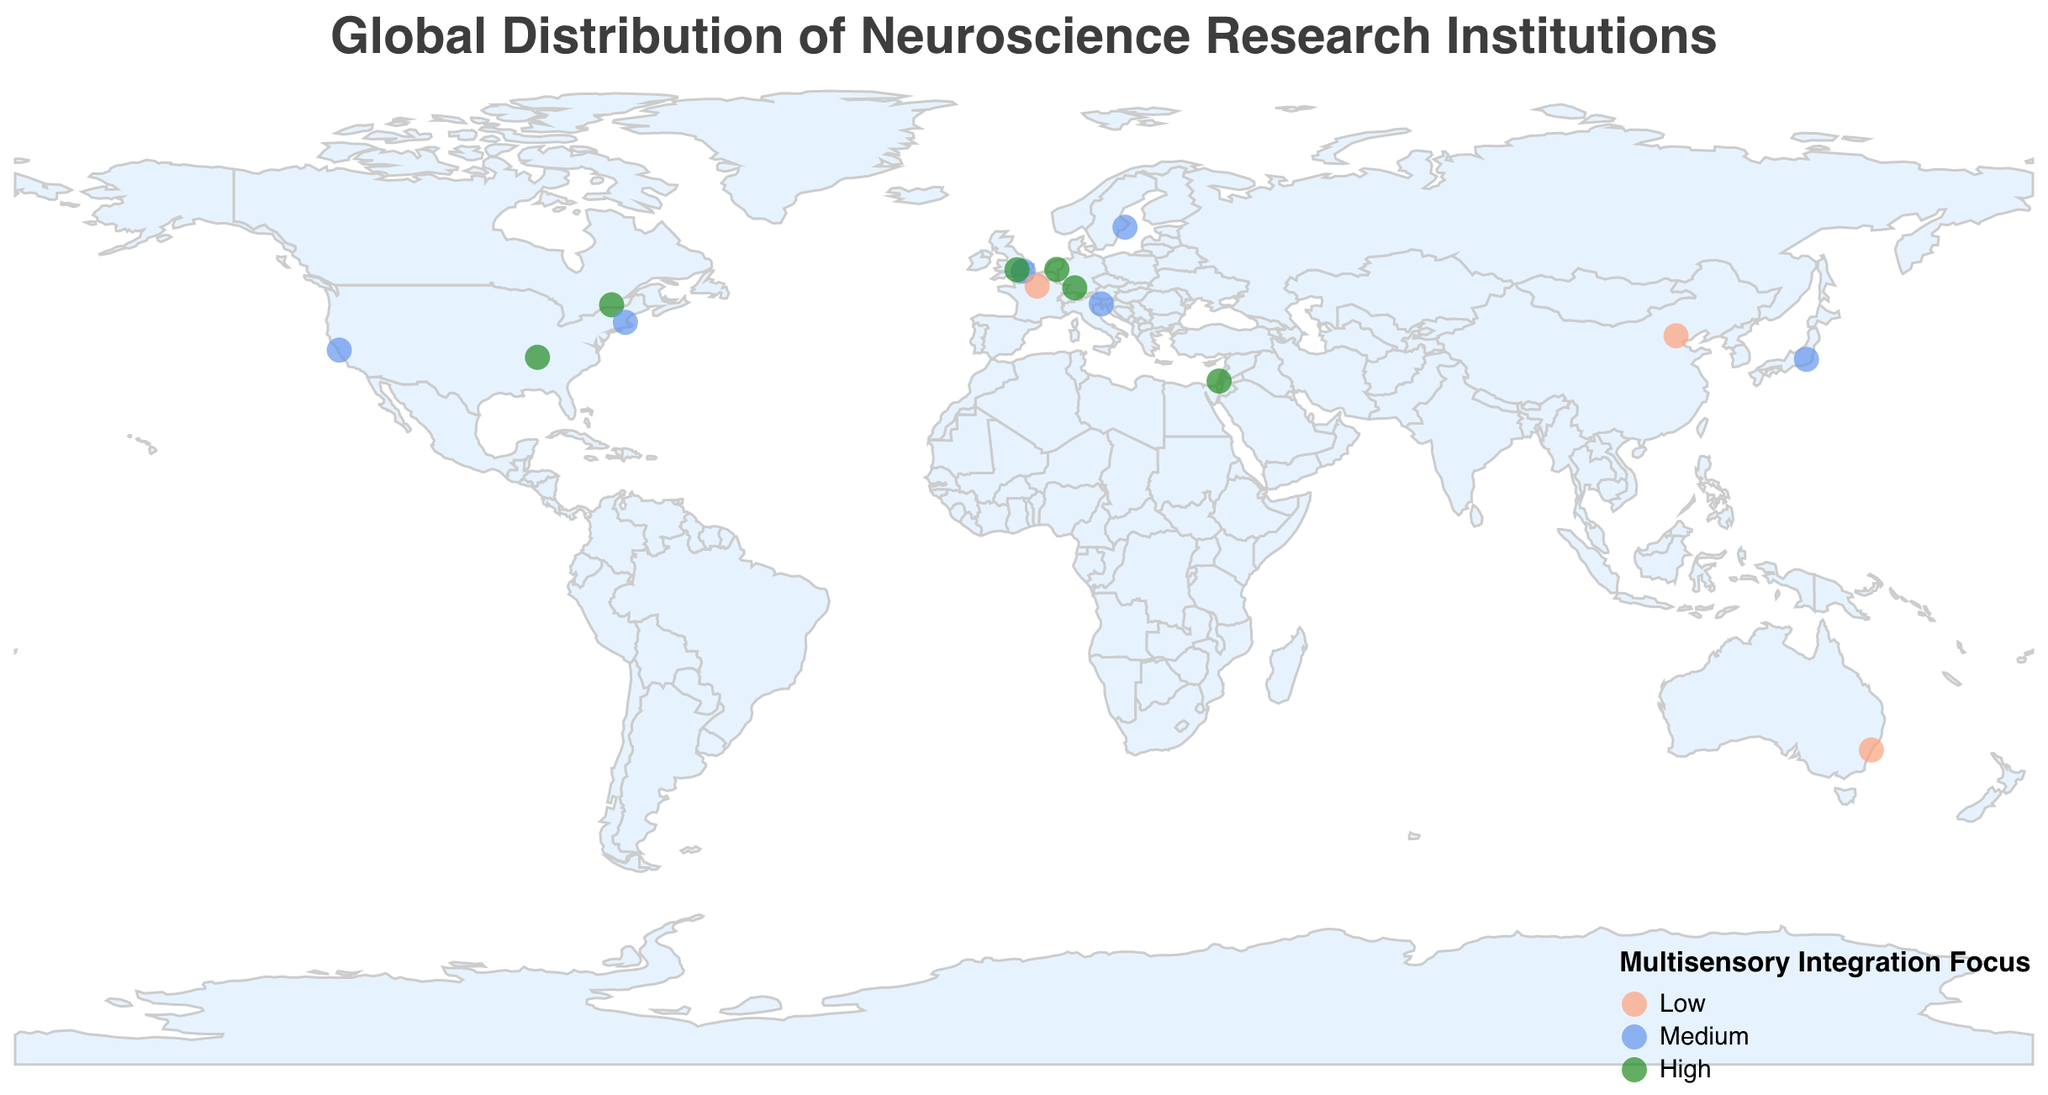How many institutions have a high focus on multisensory integration? Identify and count the institutions with the label "High" under the "Multisensory_Integration_Focus" category
Answer: 6 Which continent has the highest number of neuroscience research institutions shown in the plot? Count the number of institutions per continent based on their geographic locations. Europe has the most institutions: Max Planck Institute for Biological Cybernetics (Germany), University College London (UK), Karolinska Institute (Sweden), University of Oxford (UK), SISSA (Italy), Donders Institute (Netherlands), École Normale Supérieure (France), Weizmann Institute of Science (Israel)
Answer: Europe Which institution is located furthest south? Identify the institution with latitude farthest from the equator in the southern direction (negative latitude value)
Answer: University of Sydney How many institutions in the plot are located in North America? Count the institutions located in countries within North America: Vanderbilt Brain Institute (USA), McGill University (Canada), Harvard University (USA), Stanford University (USA)
Answer: 4 Which city has a medium focus on multisensory integration and is also the most westerly? Identify institutions with a "Medium" focus and check their longitudinal coordinates. The city with the smallest longitude (farthest west) is Stanford University in Stanford, USA
Answer: Stanford What is the approximate average longitude of the institutions with a high focus on multisensory integration? Sum the longitudes of institutions with a high focus and divide by their number: (-86.8027+9.0536-73.5772+34.8117-1.2544+5.8619)/6 = -37.9845/6
Answer: -37.98 Are there more institutions with a medium focus on multisensory integration in Europe or North America? Compare the number of institutions with a medium focus in Europe (University College London, Karolinska Institute, SISSA) and North America (Stanford University, Harvard University)
Answer: Europe Which institution located in the Western Hemisphere has the highest focus on multisensory integration? Identify institutions in the Western Hemisphere (negative longitude) and check their multisensory integration focus. Vanderbilt Brain Institute has a high focus
Answer: Vanderbilt Brain Institute What is the general trend in the geographic distribution of institutions with a low focus on multisensory integration? Identify the locations of institutions with a low focus and note their global spread; they are scattered across Australia (University of Sydney), France (École Normale Supérieure), and China (Chinese Academy of Sciences)
Answer: Scattered across three continents 